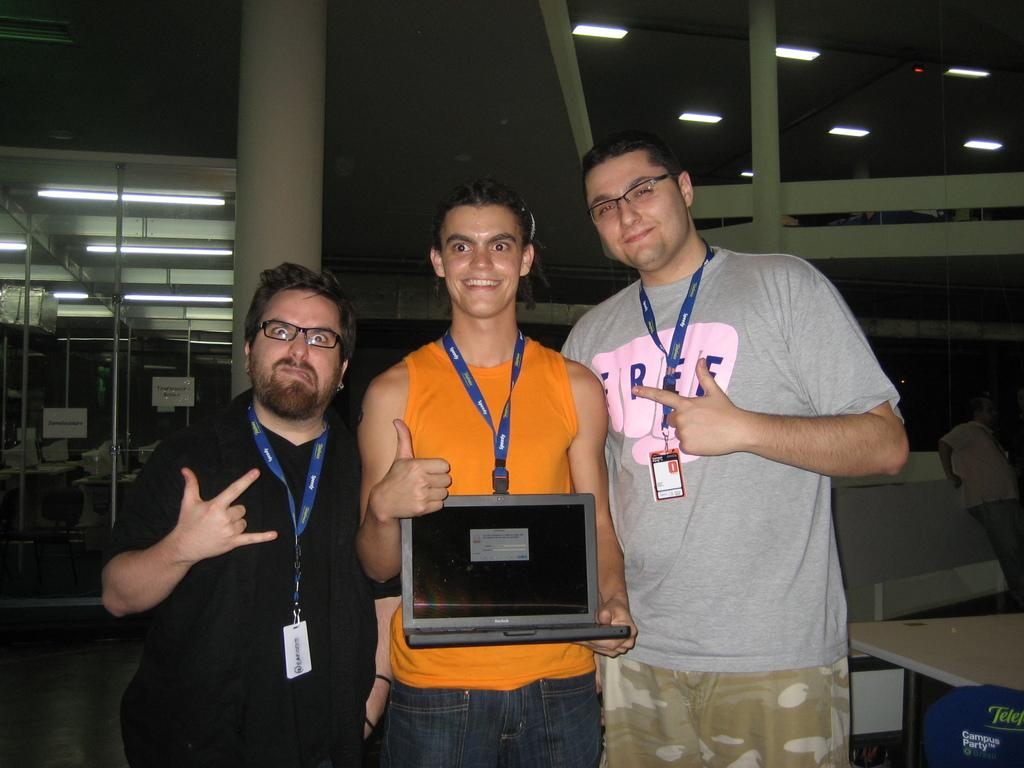How many people are visible in the image? There are three people standing in the front of the image. What object can be seen behind the people? There is a table in the image. What can be seen illuminating the scene? There are lights in the image. What type of objects are present on the table or around it? There are boxes in the image. What type of glue is being used by the people in the image? There is no glue present in the image, and the people are not using any glue. What name is written on the boxes in the image? There is no name written on the boxes in the image; they are simply described as boxes. 